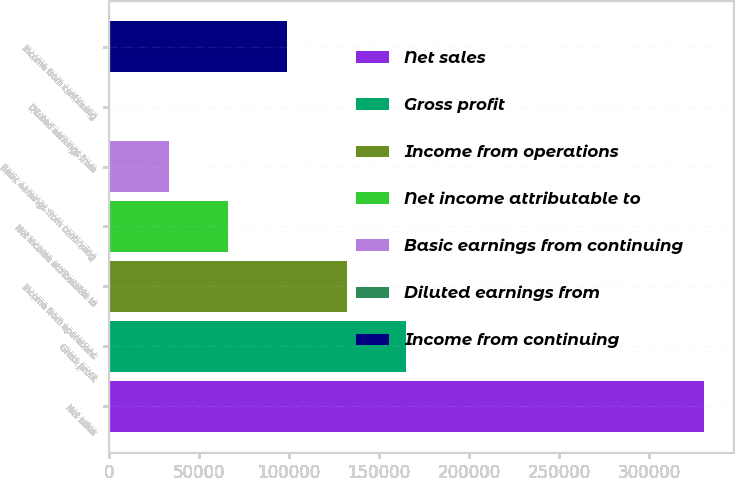<chart> <loc_0><loc_0><loc_500><loc_500><bar_chart><fcel>Net sales<fcel>Gross profit<fcel>Income from operations<fcel>Net income attributable to<fcel>Basic earnings from continuing<fcel>Diluted earnings from<fcel>Income from continuing<nl><fcel>330455<fcel>165228<fcel>132182<fcel>66091.4<fcel>33046<fcel>0.57<fcel>99136.9<nl></chart> 